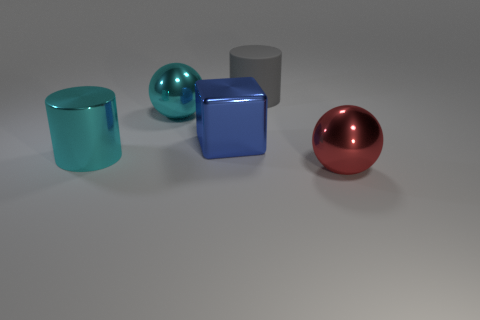What materials do the objects in the image seem to be made of? The objects in the image appear to be made of various materials that exhibit different levels of shininess and reflectivity, suggesting metallic or plastic-like properties. The cyan cylinder and the blue cube have a metallic sheen that implies they could be metallic, while the red sphere and the grey cylinder could also be metallic or have a glossy plastic finish. How does light interact with the objects in the image? The objects in the image interact with light in a way that creates reflections and highlights on their surfaces. The metallic sheen on the cyan cylinder and the blue cube indicates a highly reflective surface where light sources create bright highlights and nuanced reflections. The red sphere shows a clear and distinct reflection of the environment, while the grey cylinder displays a softer reflection. This suggests that the scene is well-lit and the objects have glossy surfaces. 